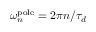Convert formula to latex. <formula><loc_0><loc_0><loc_500><loc_500>\omega _ { n } ^ { p o l e } = 2 \pi n / \tau _ { d }</formula> 